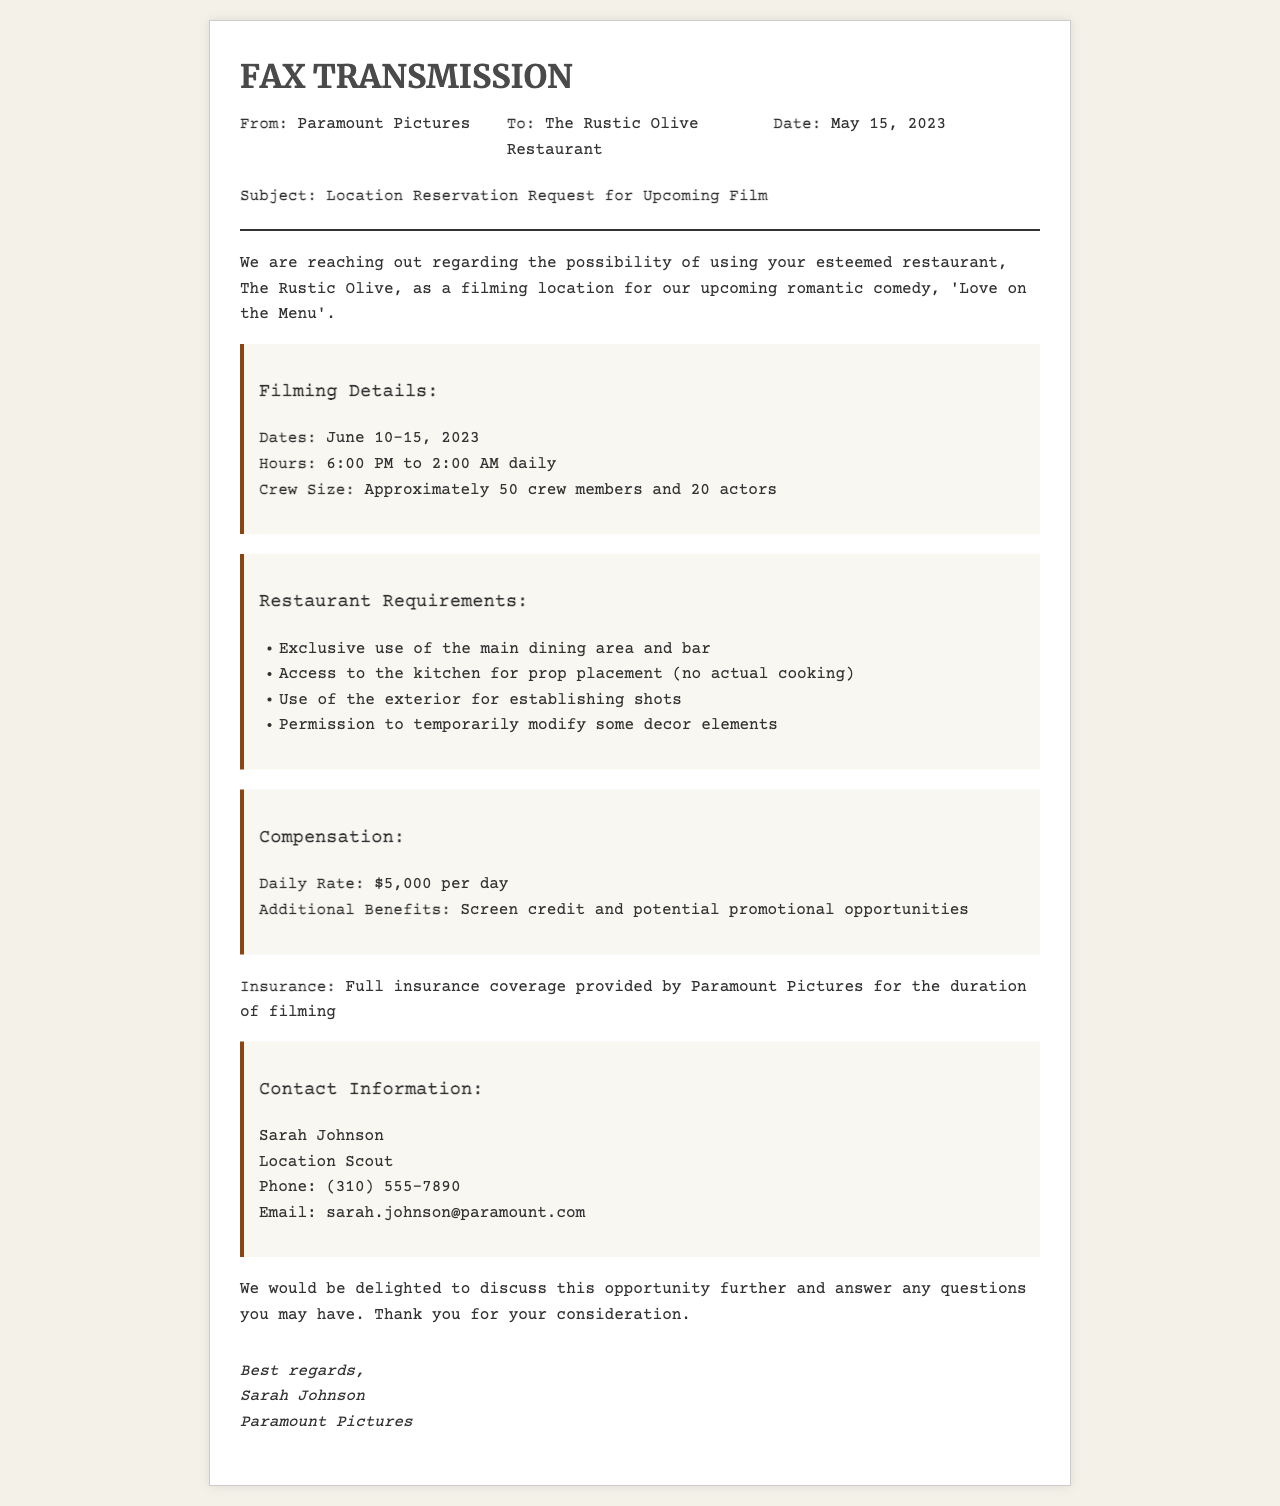what is the name of the film? The name of the film mentioned in the document is 'Love on the Menu'.
Answer: 'Love on the Menu' what are the filming dates? The filming dates specified in the document are June 10-15, 2023.
Answer: June 10-15, 2023 what is the crew size? The crew size for the filming is mentioned as approximately 50 crew members and 20 actors.
Answer: Approximately 50 crew members and 20 actors how much is the daily rate for filming? The daily rate for filming is stated as $5,000 per day.
Answer: $5,000 per day who is the contact person at Paramount Pictures? The contact person at Paramount Pictures is Sarah Johnson.
Answer: Sarah Johnson what is one of the restaurant requirements? One of the restaurant requirements is exclusive use of the main dining area and bar.
Answer: Exclusive use of the main dining area and bar what time does filming start each day? Filming starts at 6:00 PM each day.
Answer: 6:00 PM what kind of coverage is provided for insurance? Full insurance coverage is provided by Paramount Pictures for the duration of filming.
Answer: Full insurance coverage what is the purpose of this fax? The purpose of this fax is to request a reservation for filming at the restaurant.
Answer: Reservation request for filming 